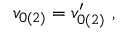<formula> <loc_0><loc_0><loc_500><loc_500>\begin{array} { r } { v _ { 0 ( 2 ) } = v _ { 0 ( 2 ) } ^ { \prime } , } \end{array}</formula> 